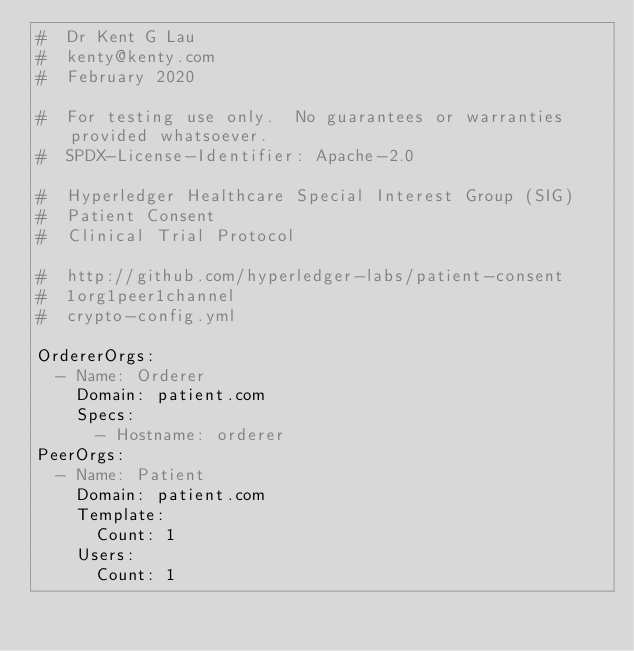Convert code to text. <code><loc_0><loc_0><loc_500><loc_500><_YAML_>#  Dr Kent G Lau
#  kenty@kenty.com
#  February 2020

#  For testing use only.  No guarantees or warranties provided whatsoever.
#  SPDX-License-Identifier: Apache-2.0

#  Hyperledger Healthcare Special Interest Group (SIG)
#  Patient Consent
#  Clinical Trial Protocol

#  http://github.com/hyperledger-labs/patient-consent
#  1org1peer1channel
#  crypto-config.yml

OrdererOrgs:
  - Name: Orderer
    Domain: patient.com
    Specs:
      - Hostname: orderer
PeerOrgs:
  - Name: Patient
    Domain: patient.com
    Template:
      Count: 1
    Users:
      Count: 1
</code> 